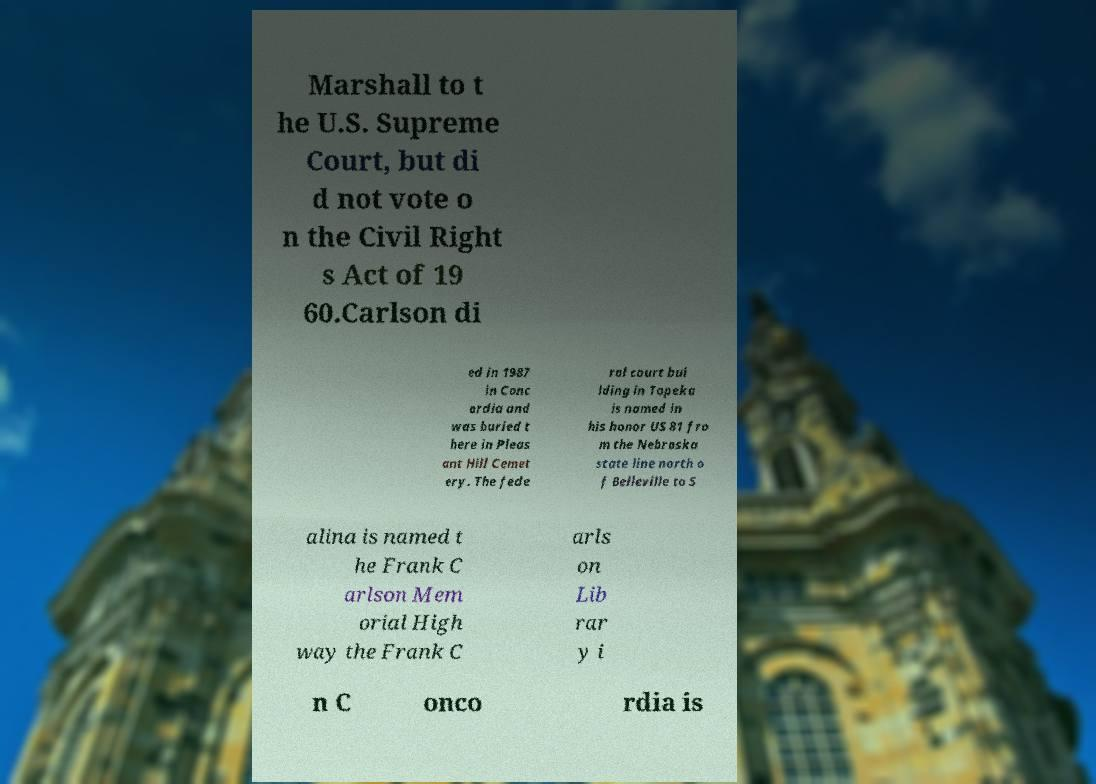Could you assist in decoding the text presented in this image and type it out clearly? Marshall to t he U.S. Supreme Court, but di d not vote o n the Civil Right s Act of 19 60.Carlson di ed in 1987 in Conc ordia and was buried t here in Pleas ant Hill Cemet ery. The fede ral court bui lding in Topeka is named in his honor US 81 fro m the Nebraska state line north o f Belleville to S alina is named t he Frank C arlson Mem orial High way the Frank C arls on Lib rar y i n C onco rdia is 